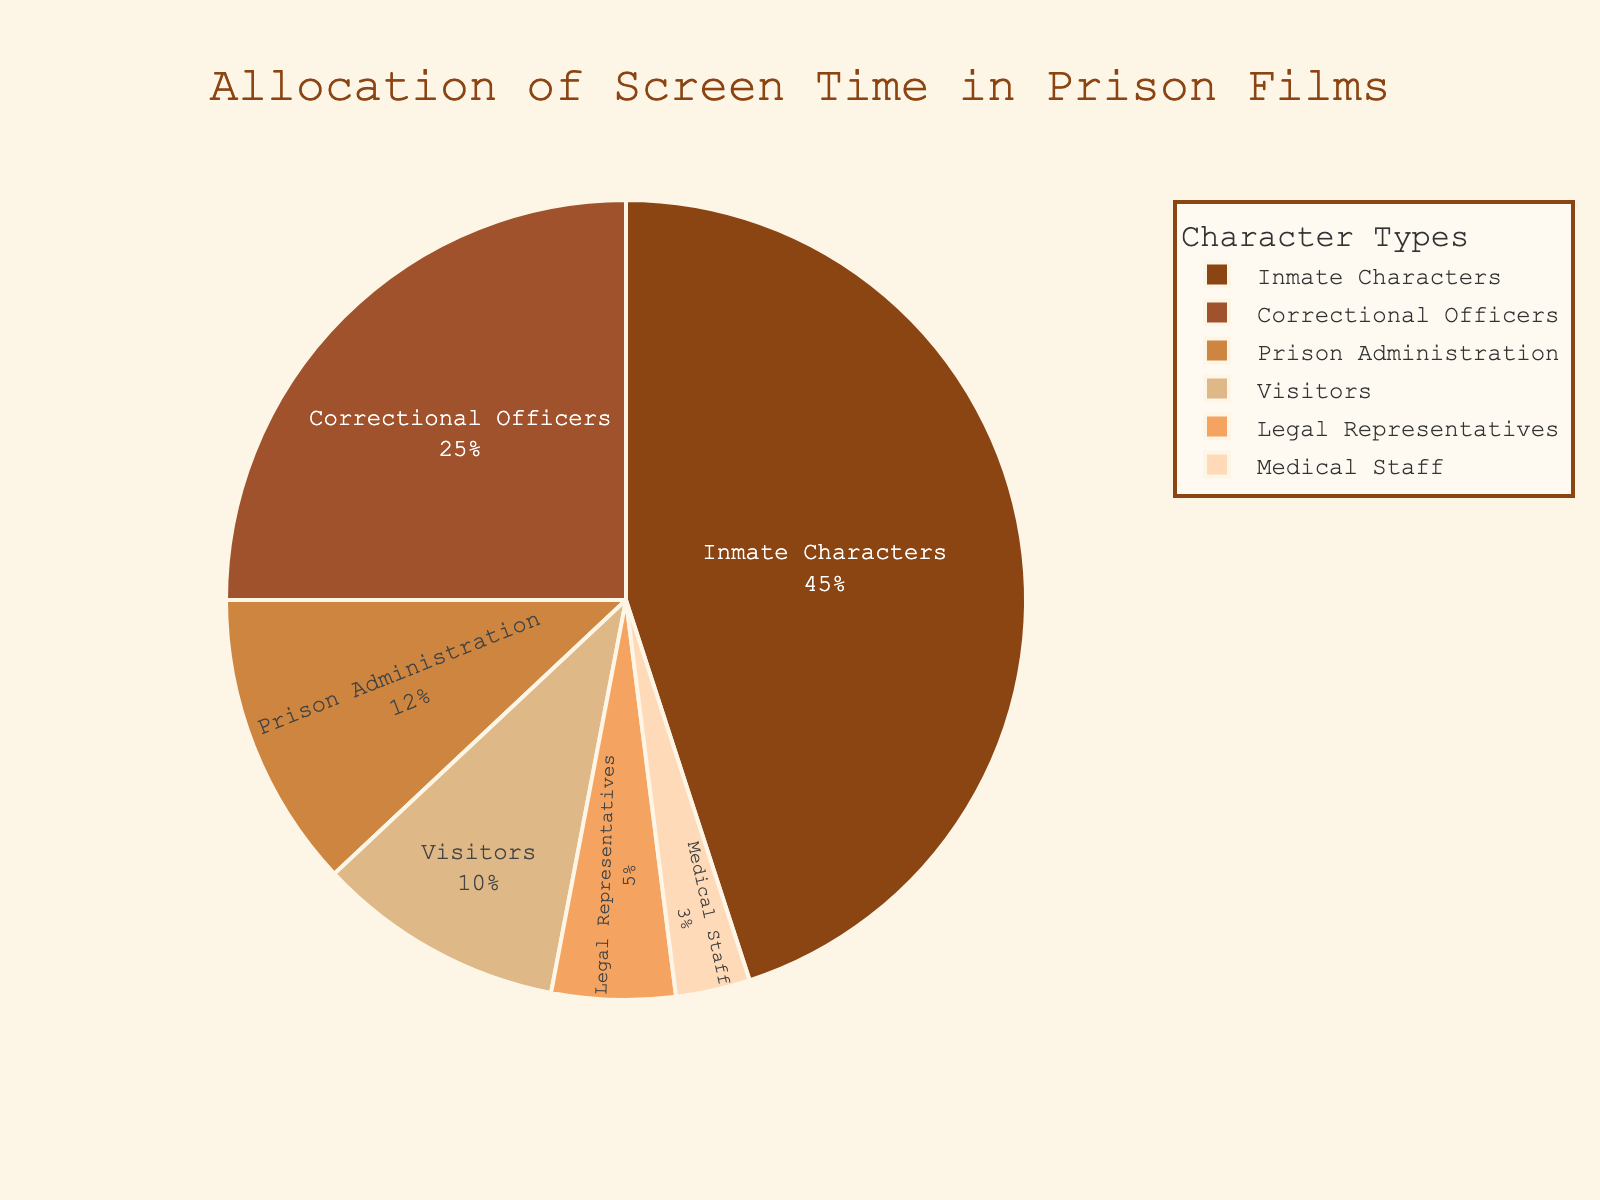What is the percentage of screen time allocated to inmate characters? The figure shows the allocation of screen time among various character types. Inmate characters have a segment labeled with their percentage.
Answer: 45% Which character type received the least screen time? By observing the pie chart, the segment with the smallest size and the label indicating the lowest percentage corresponds to the character type with the least screen time.
Answer: Medical Staff How much more screen time do correctional officers receive compared to prison administration? Look at the segments for correctional officers and prison administration. Subtract the percentage of prison administration from the percentage of correctional officers. 25% - 12% = 13%
Answer: 13% What is the combined screen time percentage dedicated to visitors and legal representatives? Add the percentages of visitors and legal representatives. 10% + 5% = 15%
Answer: 15% Which character type has the second highest screen time allocation? The figure indicates that inmate characters have the highest screen time. The second highest segment belongs to the character type with the next largest slice and percentage.
Answer: Correctional Officers How does the screen time of prison administration compare to that of legal representatives? Look at the percentages for prison administration and legal representatives. 12% is greater than 5%.
Answer: Prison Administration has more screen time Are inmates given more than double the screen time of visitors? Compare the percentage allocated to inmate characters with twice the percentage allocated to visitors. 2 * 10% = 20%. 45% (Inmates) > 20%
Answer: Yes What percentage of screen time is not dedicated to inmate characters? Subtract the percentage of inmate characters from 100%. 100% - 45% = 55%
Answer: 55% Do visitors receive more screen time than medical staff? Compare the percentages for visitors and medical staff. 10% (Visitors) > 3% (Medical Staff)
Answer: Yes 